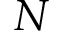Convert formula to latex. <formula><loc_0><loc_0><loc_500><loc_500>N</formula> 